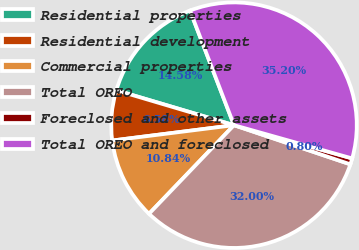Convert chart to OTSL. <chart><loc_0><loc_0><loc_500><loc_500><pie_chart><fcel>Residential properties<fcel>Residential development<fcel>Commercial properties<fcel>Total OREO<fcel>Foreclosed and other assets<fcel>Total OREO and foreclosed<nl><fcel>14.58%<fcel>6.58%<fcel>10.84%<fcel>32.0%<fcel>0.8%<fcel>35.2%<nl></chart> 